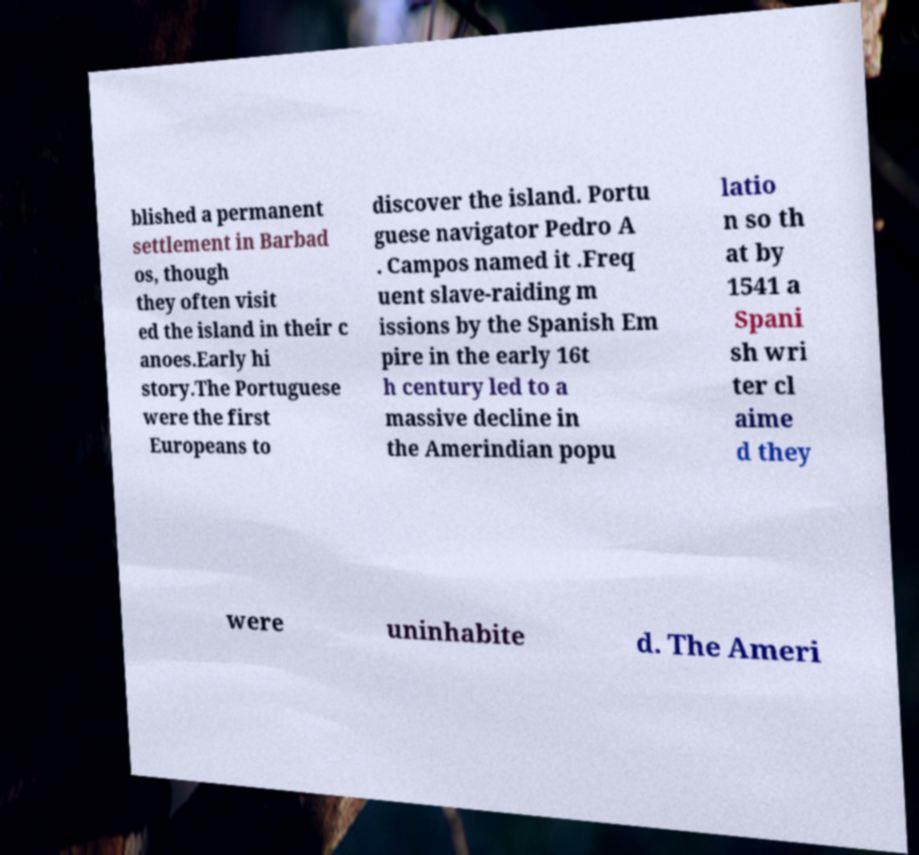Please identify and transcribe the text found in this image. blished a permanent settlement in Barbad os, though they often visit ed the island in their c anoes.Early hi story.The Portuguese were the first Europeans to discover the island. Portu guese navigator Pedro A . Campos named it .Freq uent slave-raiding m issions by the Spanish Em pire in the early 16t h century led to a massive decline in the Amerindian popu latio n so th at by 1541 a Spani sh wri ter cl aime d they were uninhabite d. The Ameri 